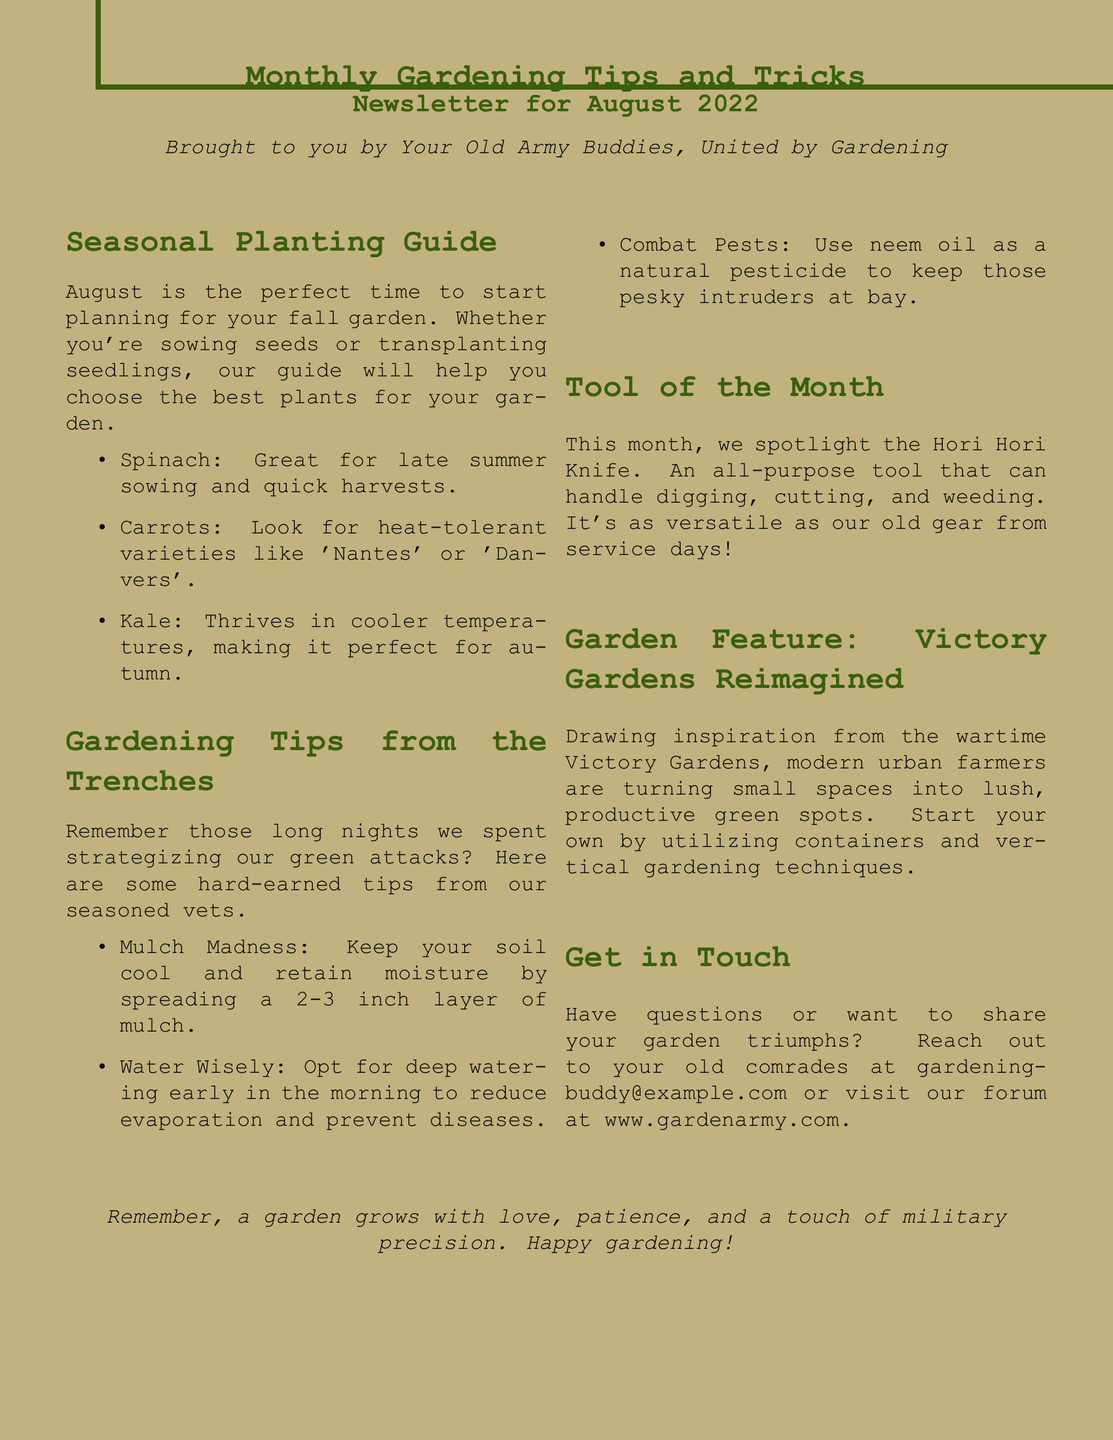What is the title of the newsletter? The title is prominently displayed at the top of the document.
Answer: Monthly Gardening Tips and Tricks What month is the newsletter for? Located right below the title, it specifies the month covered by the publication.
Answer: August 2022 What is the first item listed in the Seasonal Planting Guide? The first item is listed in the bullet points of the guide section.
Answer: Spinach What tool is spotlighted as the Tool of the Month? This information is found in the specific section dedicated to the tool.
Answer: Hori Hori Knife What is a recommended watering time mentioned in the gardening tips? The tips include advice on when to water your plants effectively.
Answer: Early in the morning What type of gardens are featured in the Garden Feature section? The name of the garden type is mentioned in the title of that section.
Answer: Victory Gardens Reimagined What is the email provided for reaching out? The contact information is found in the "Get in Touch" section.
Answer: gardeningbuddy@example.com How deep should the mulch layer be according to the gardening tips? This detail is noted in the instructions for mulching.
Answer: 2-3 inch What natural pesticide is recommended to combat pests? The document specifies a particular product for pest control.
Answer: Neem oil 